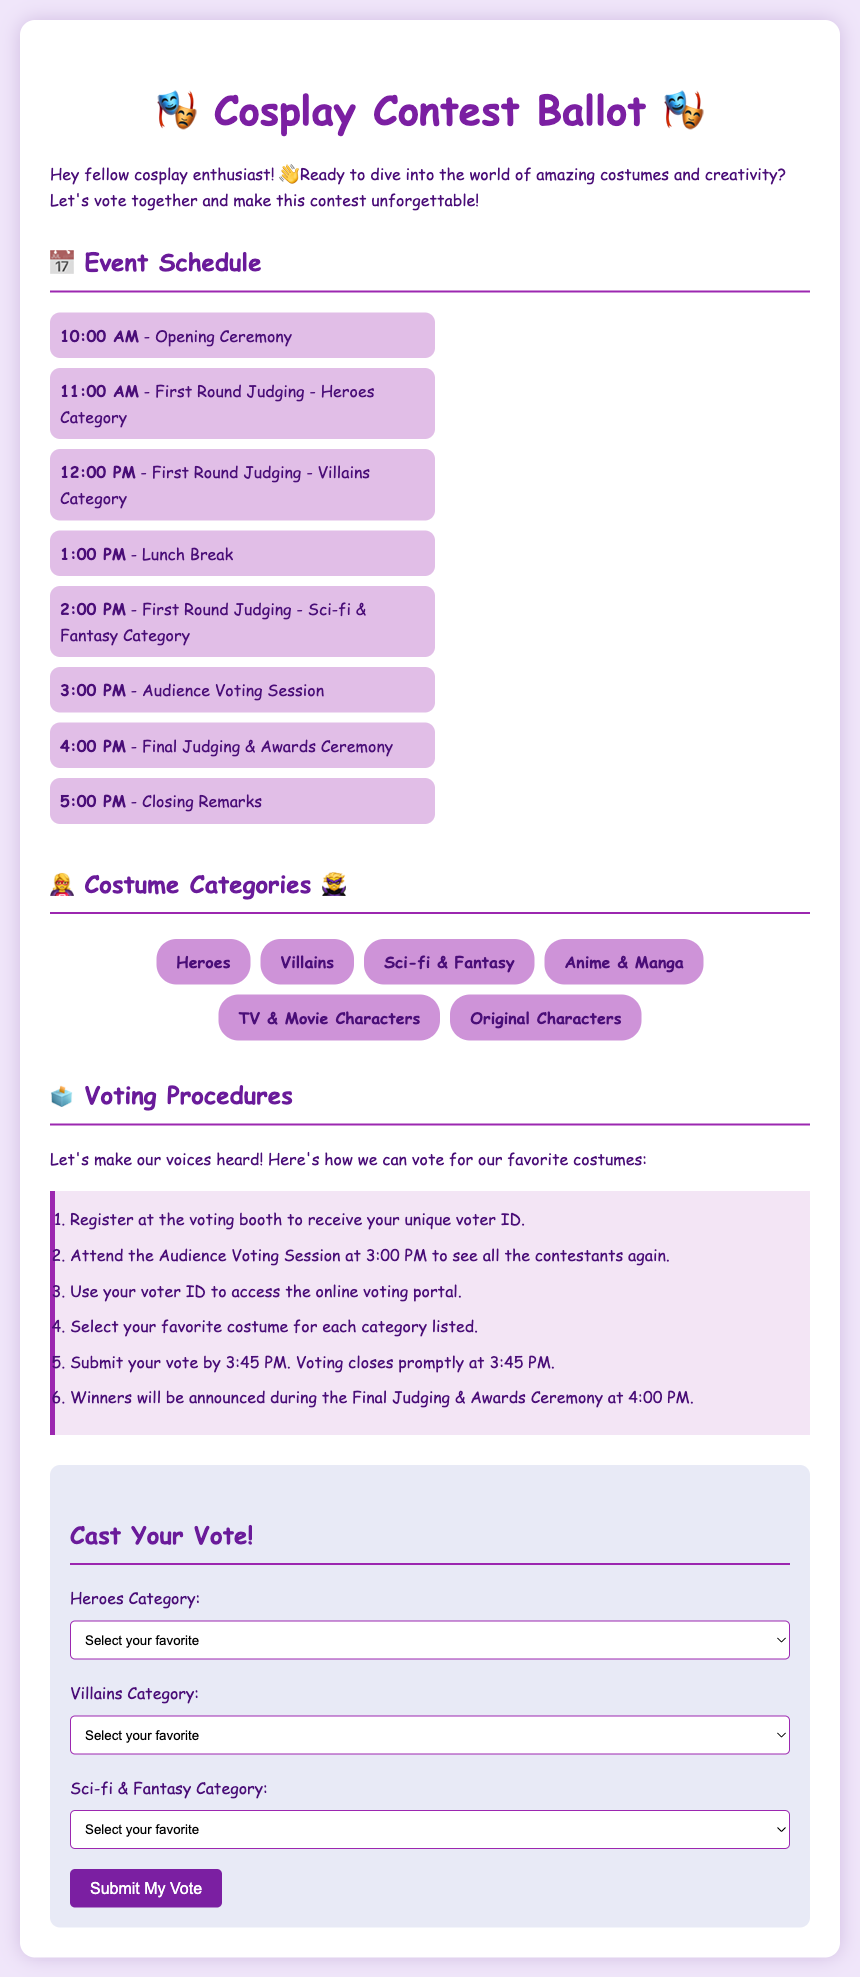what time does the opening ceremony start? The opening ceremony starts at 10:00 AM, as listed in the event schedule.
Answer: 10:00 AM how many costume categories are there? There are a total of six costume categories mentioned in the document.
Answer: 6 what time is the audience voting session? The audience voting session is scheduled for 3:00 PM, according to the event times.
Answer: 3:00 PM what is the last time to submit a vote? The last time to submit a vote is 3:45 PM, as stated in the voting procedures.
Answer: 3:45 PM which character is in the Heroes category? Superhero A is one of the characters listed in the Heroes category for selection.
Answer: Superhero A how many steps are there in the voting procedure? There are six steps outlined in the voting procedures.
Answer: 6 which category has a final judging and awards ceremony? The final judging and awards ceremony is mentioned for all costume categories collectively.
Answer: All categories what do you receive at the voting booth? At the voting booth, you receive a unique voter ID for voting participation.
Answer: Unique voter ID 